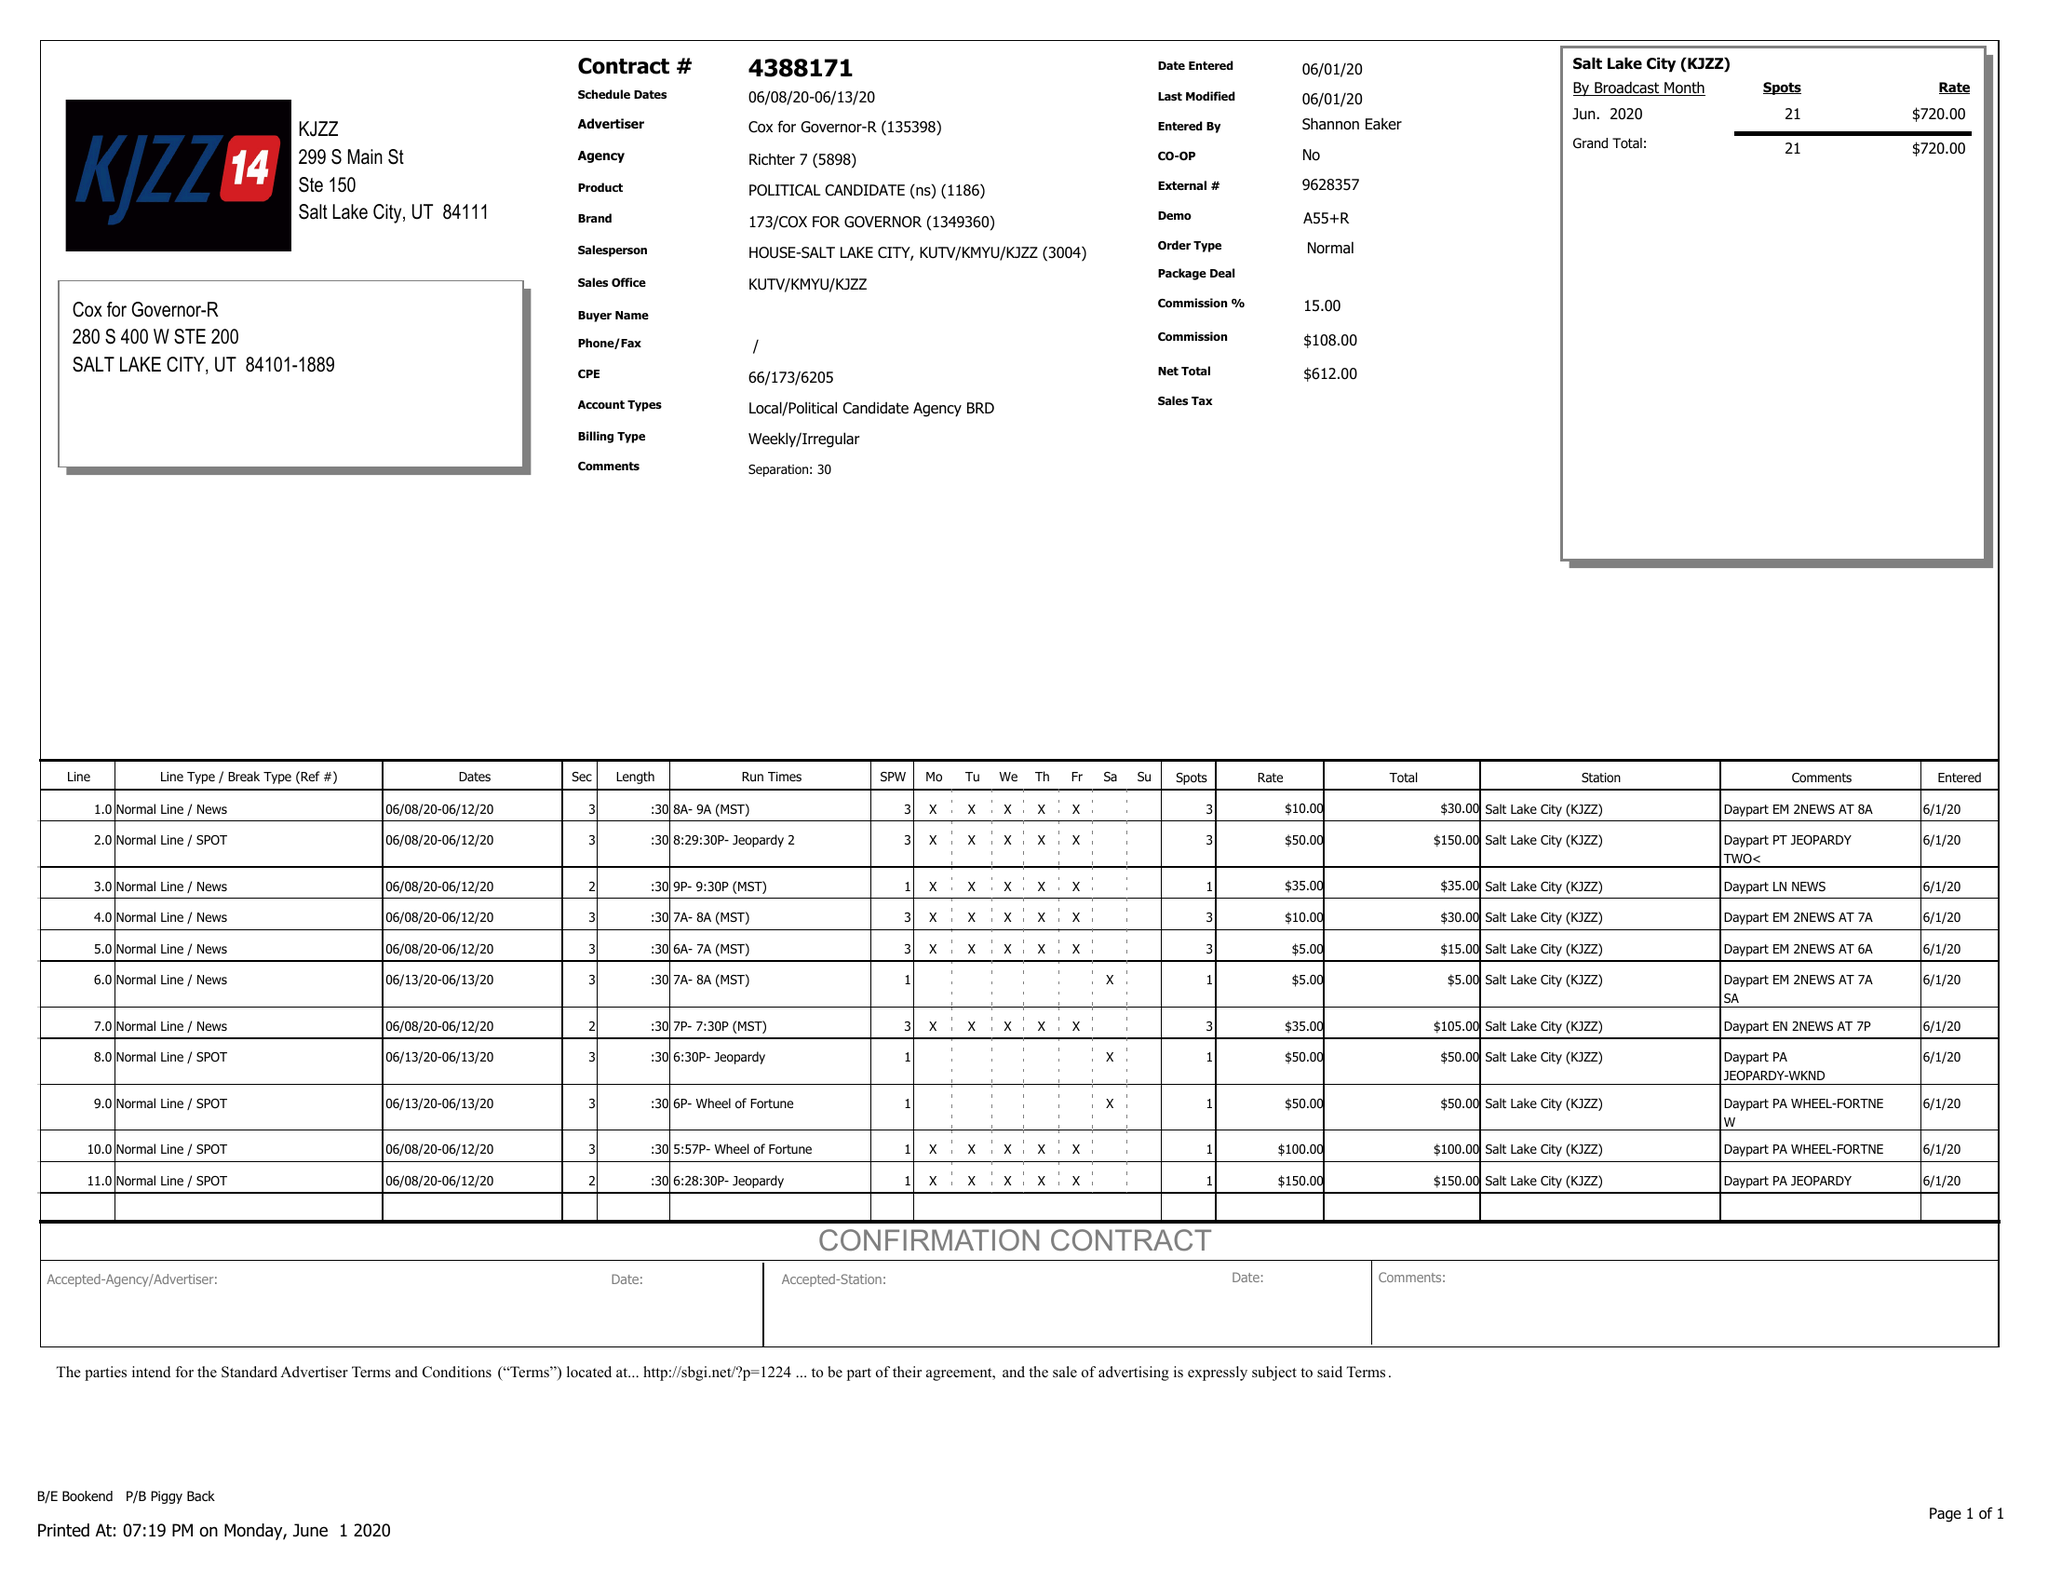What is the value for the advertiser?
Answer the question using a single word or phrase. COX FOR GOVERNOR-R 